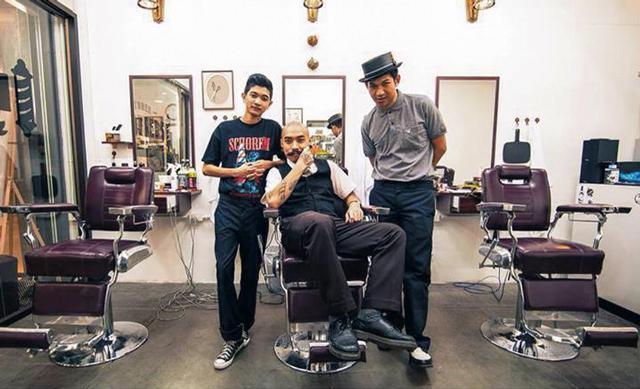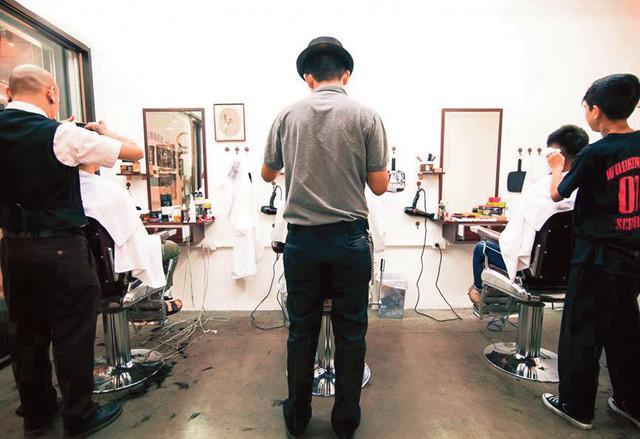The first image is the image on the left, the second image is the image on the right. Considering the images on both sides, is "At least one person is wearing eyeglasses in one of the images." valid? Answer yes or no. No. The first image is the image on the left, the second image is the image on the right. Evaluate the accuracy of this statement regarding the images: "A forward-facing man who is not a customer sits on a barber chair in the center of one scene.". Is it true? Answer yes or no. Yes. 